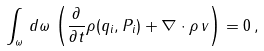Convert formula to latex. <formula><loc_0><loc_0><loc_500><loc_500>\int _ { \omega } \, d \omega \, \left ( \frac { \partial } { \partial t } \rho ( q _ { i } , P _ { i } ) + \nabla \cdot \rho \, { v } \right ) = 0 \, ,</formula> 